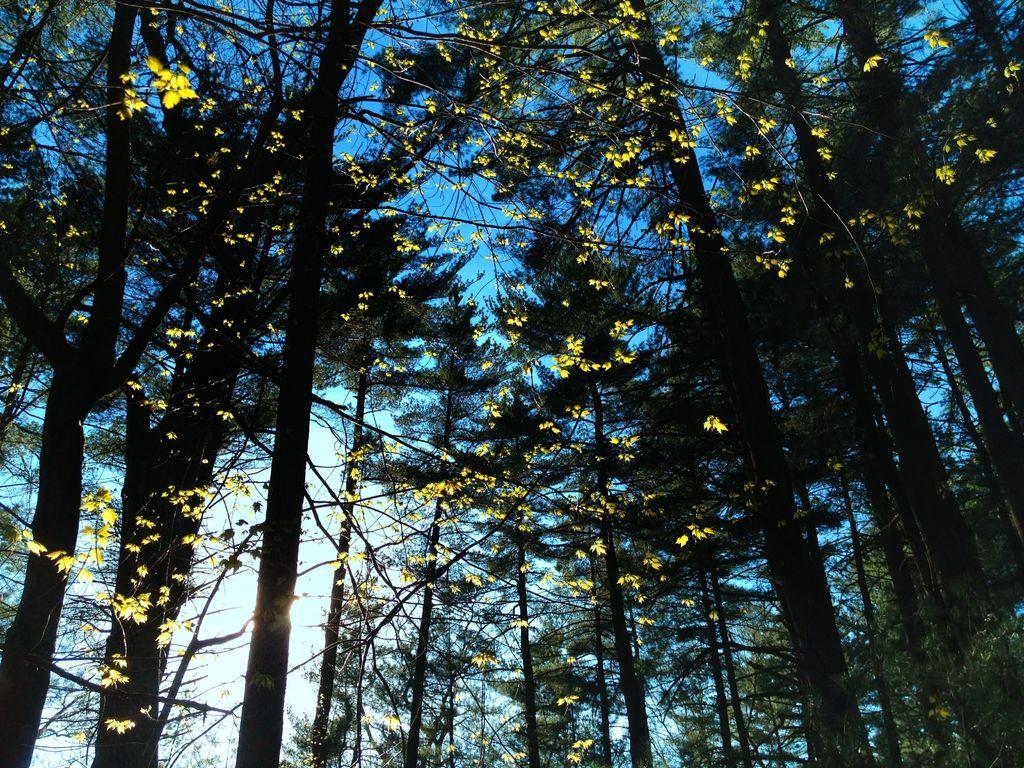What type of vegetation can be seen in the image? There are trees in the image. What part of the natural environment is visible in the image? The sky is visible in the background of the image. What type of crime is being committed on the island in the image? There is no island or crime present in the image; it features trees and the sky. How does the brake system work on the trees in the image? There is no brake system present on the trees in the image, as trees do not have brake systems. 